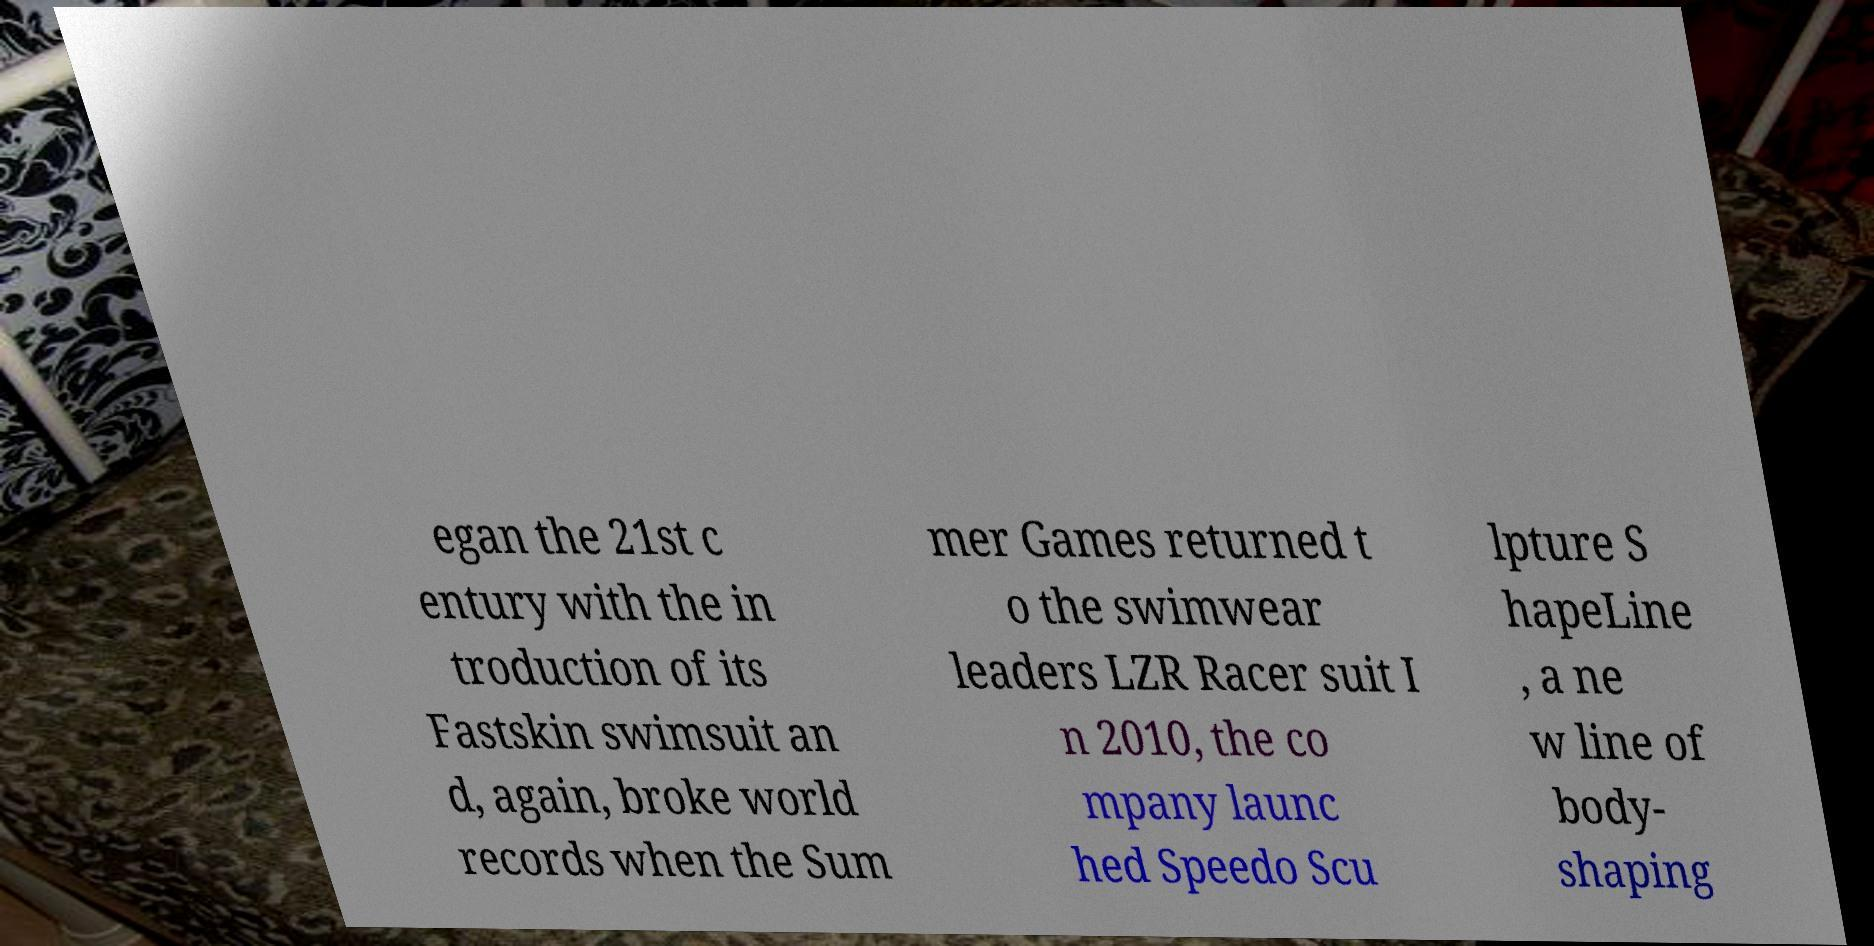I need the written content from this picture converted into text. Can you do that? egan the 21st c entury with the in troduction of its Fastskin swimsuit an d, again, broke world records when the Sum mer Games returned t o the swimwear leaders LZR Racer suit I n 2010, the co mpany launc hed Speedo Scu lpture S hapeLine , a ne w line of body- shaping 